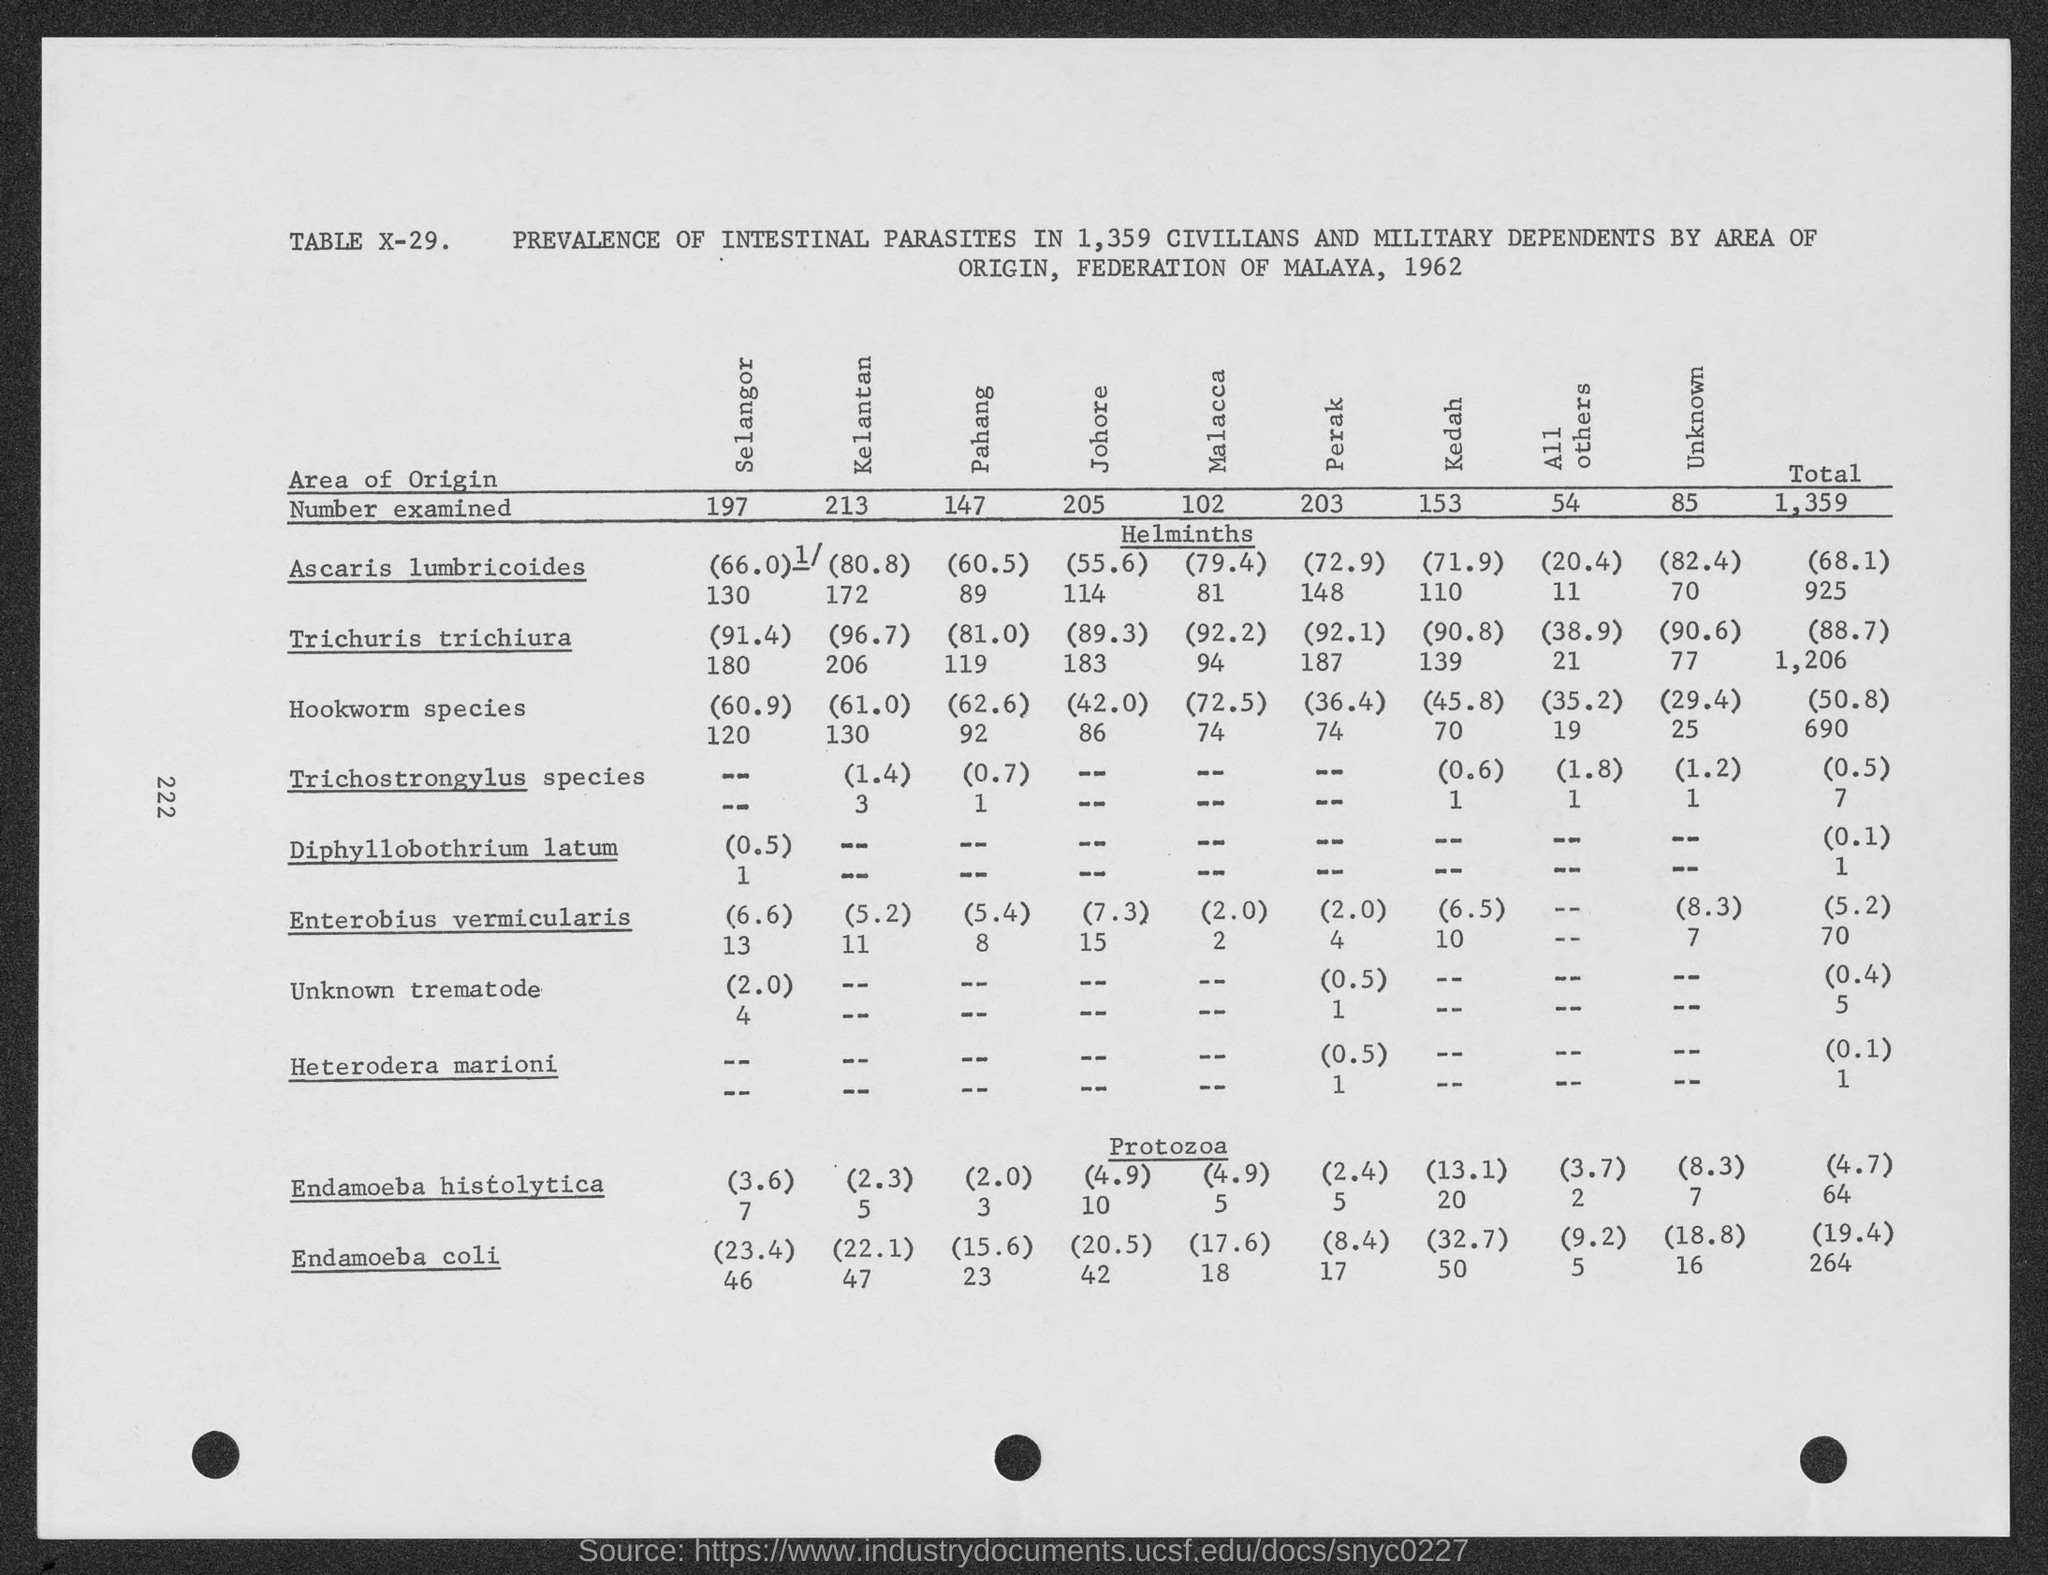What does the data suggest about the prevalence of intestinal parasites across different areas? The data indicates regional variations in the prevalence of different intestinal parasites. For instance, Ascaris lumbricoides appears more frequent in certain areas like Kelantan, compared to others like Perlis. Such variations can be influenced by local sanitation, healthcare practices, and socioeconomic factors. Overall, the data underscores the need for targeted health interventions. 